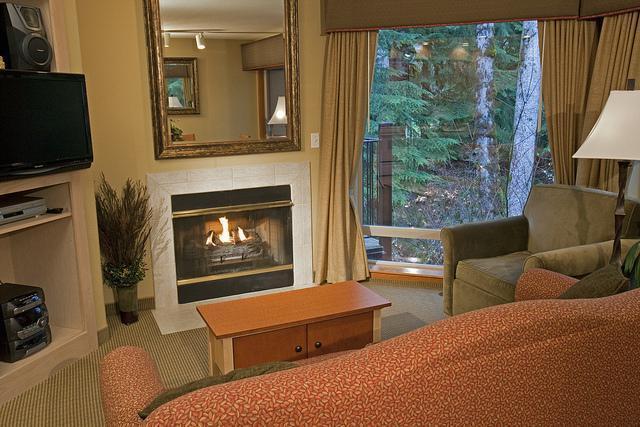How many couches are there?
Give a very brief answer. 2. How many rolls of white toilet paper are in the bathroom?
Give a very brief answer. 0. 